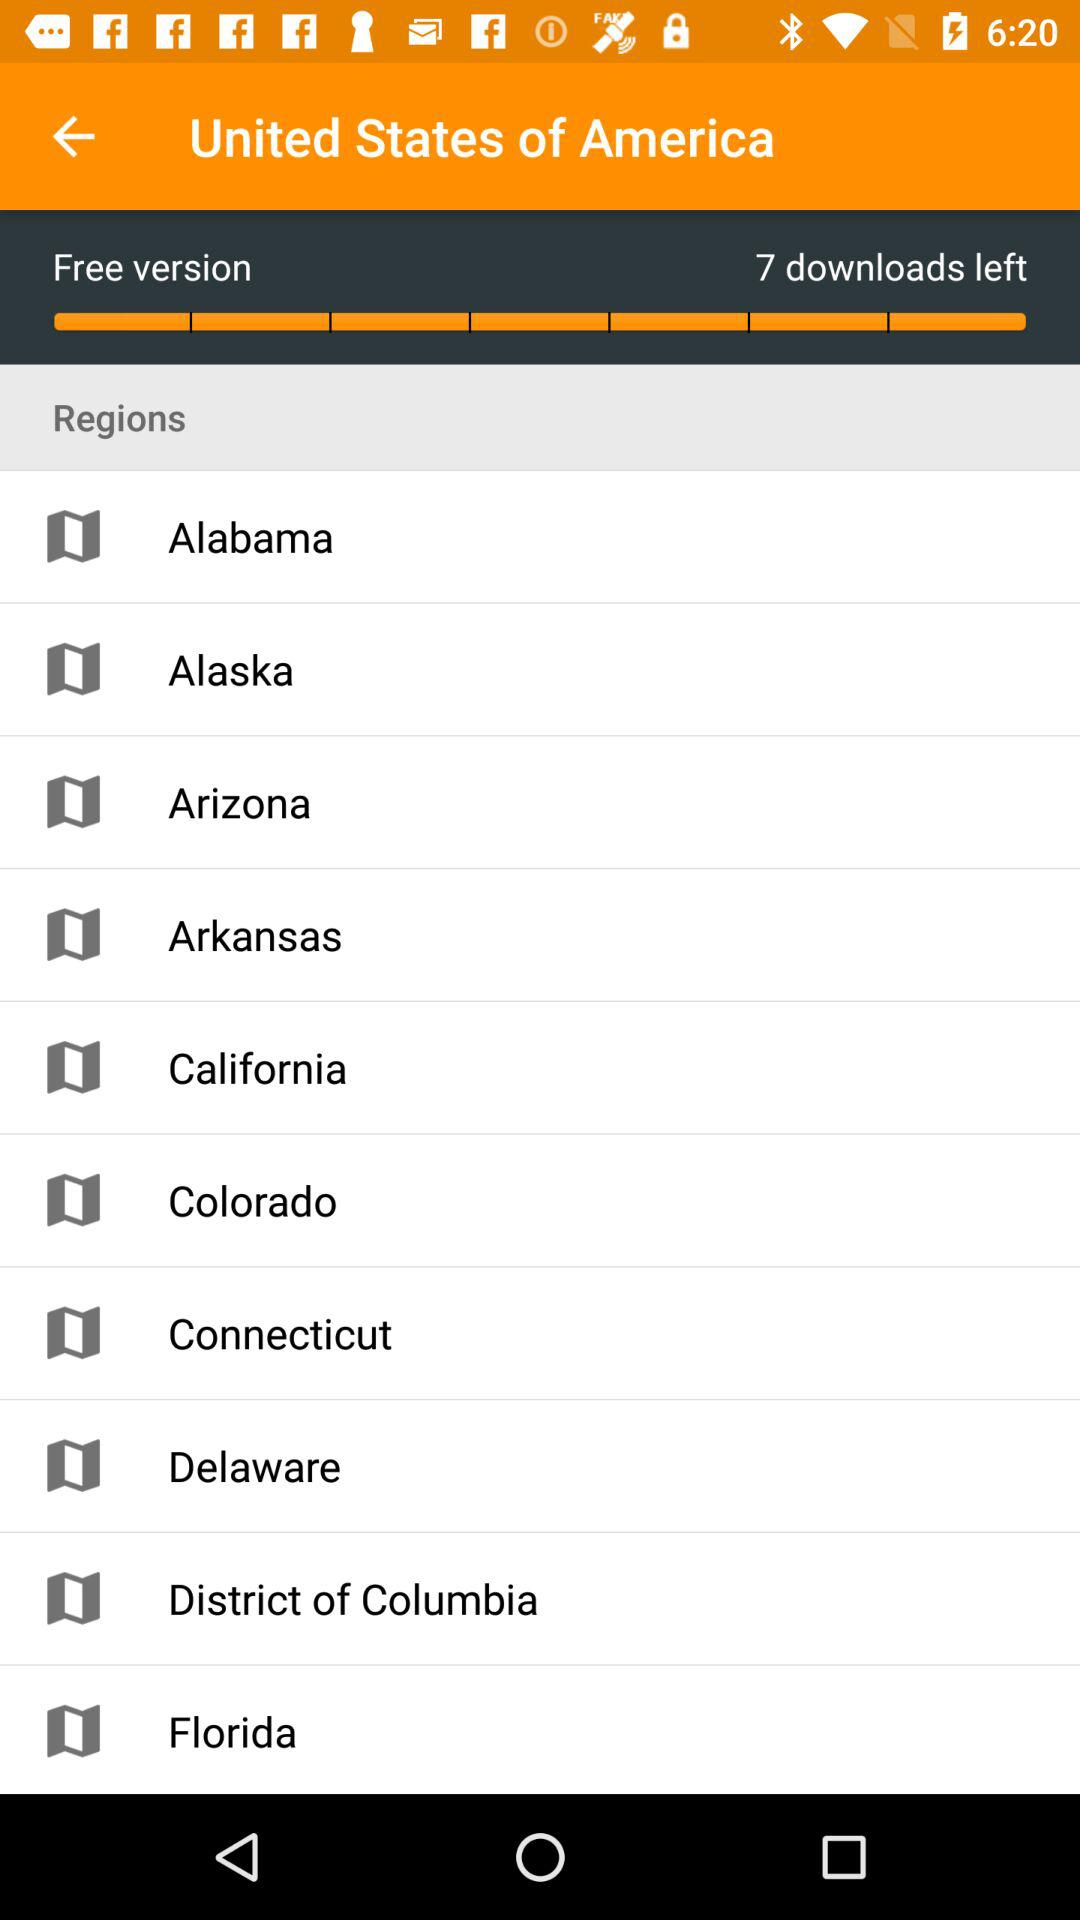How many downloads are left?
Answer the question using a single word or phrase. 7 